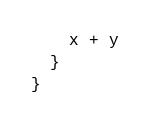Convert code to text. <code><loc_0><loc_0><loc_500><loc_500><_Scala_>    x + y
  }
}
</code> 